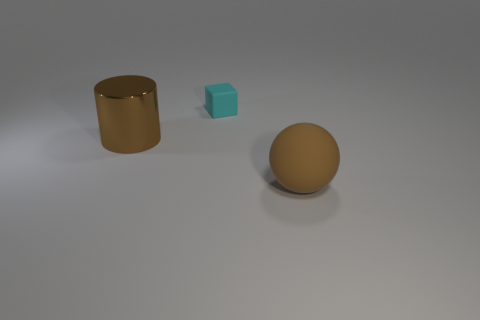How could these objects be used in a practical context? The cylindrical object could serve as a container or a standalone decorative piece. The cyan block, given its small size and shape, might be a child's toy block or an artistic element, while the sphere could function as a decorative ball or be part of a larger mechanical assembly. 